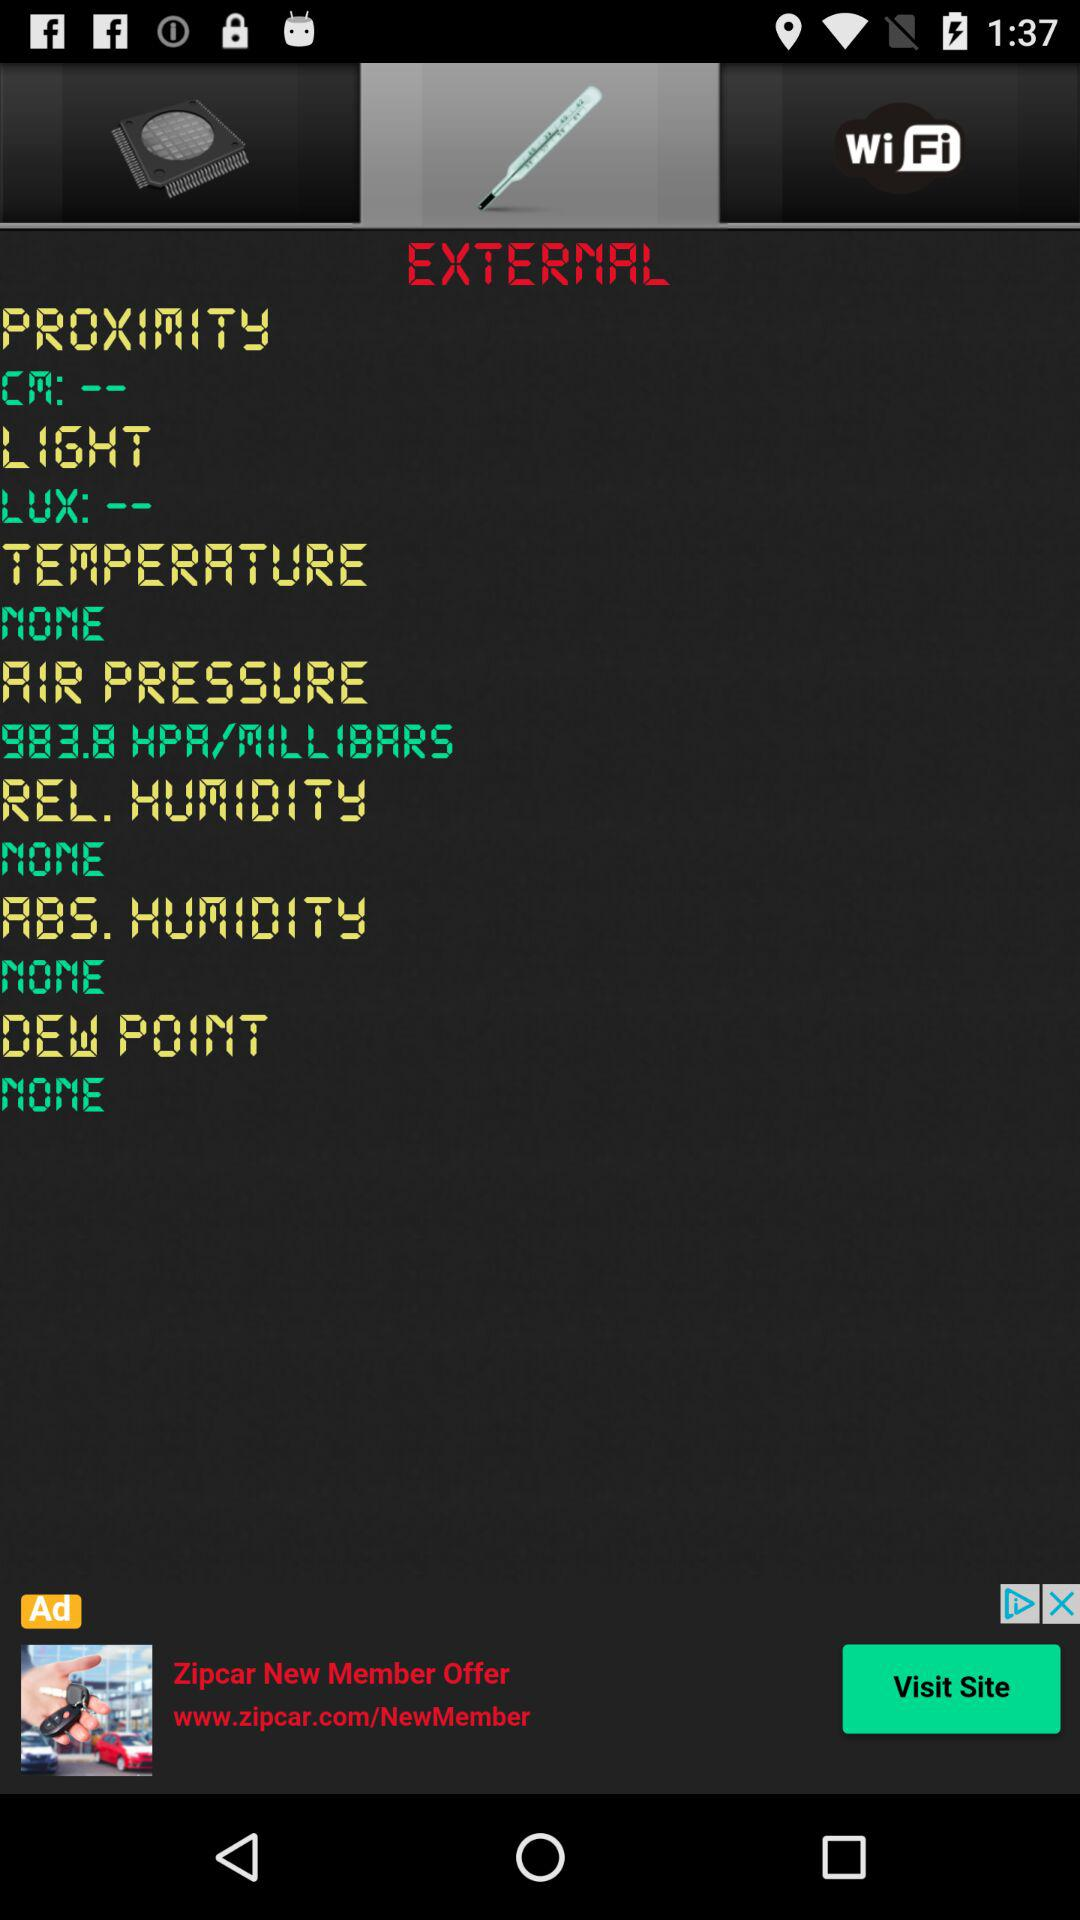What is the "ABS. HUMIDITY"? "ABS. HUMIDITY" is "NONE". 